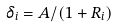Convert formula to latex. <formula><loc_0><loc_0><loc_500><loc_500>\delta _ { i } = A / ( 1 + R _ { i } )</formula> 